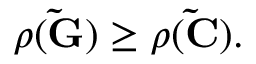Convert formula to latex. <formula><loc_0><loc_0><loc_500><loc_500>\begin{array} { r } { \rho ( \tilde { G } ) \geq \rho ( \tilde { C } ) . } \end{array}</formula> 